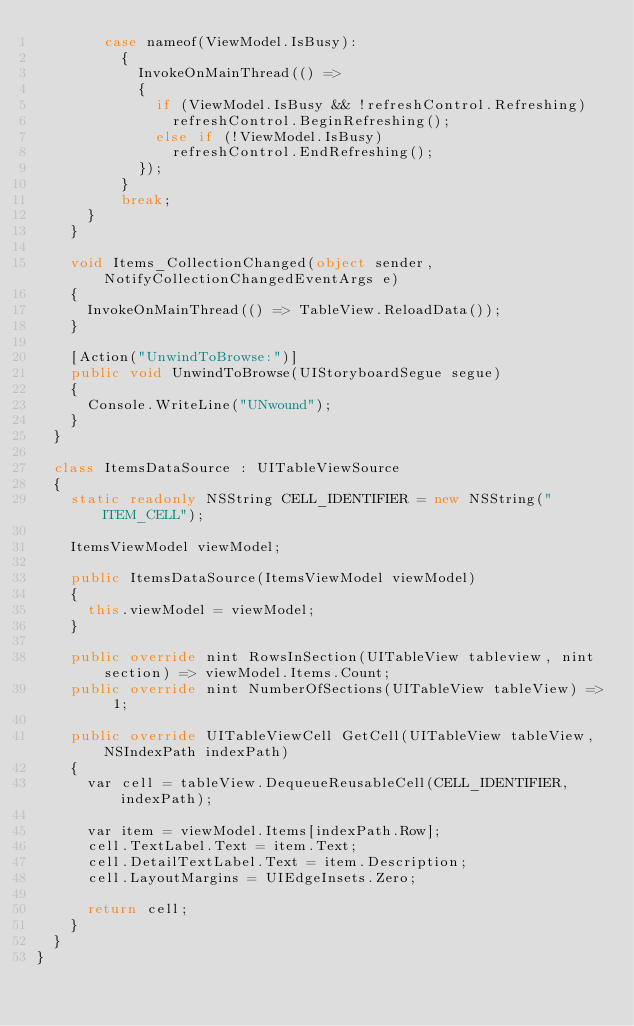<code> <loc_0><loc_0><loc_500><loc_500><_C#_>				case nameof(ViewModel.IsBusy):
					{
						InvokeOnMainThread(() =>
						{
							if (ViewModel.IsBusy && !refreshControl.Refreshing)
								refreshControl.BeginRefreshing();
							else if (!ViewModel.IsBusy)
								refreshControl.EndRefreshing();
						});
					}
					break;
			}
		}

		void Items_CollectionChanged(object sender, NotifyCollectionChangedEventArgs e)
		{
			InvokeOnMainThread(() => TableView.ReloadData());
		}

		[Action("UnwindToBrowse:")]
		public void UnwindToBrowse(UIStoryboardSegue segue)
		{
			Console.WriteLine("UNwound");
		}
	}

	class ItemsDataSource : UITableViewSource
	{
		static readonly NSString CELL_IDENTIFIER = new NSString("ITEM_CELL");

		ItemsViewModel viewModel;

		public ItemsDataSource(ItemsViewModel viewModel)
		{
			this.viewModel = viewModel;
		}

		public override nint RowsInSection(UITableView tableview, nint section) => viewModel.Items.Count;
		public override nint NumberOfSections(UITableView tableView) => 1;

		public override UITableViewCell GetCell(UITableView tableView, NSIndexPath indexPath)
		{
			var cell = tableView.DequeueReusableCell(CELL_IDENTIFIER, indexPath);

			var item = viewModel.Items[indexPath.Row];
			cell.TextLabel.Text = item.Text;
			cell.DetailTextLabel.Text = item.Description;
			cell.LayoutMargins = UIEdgeInsets.Zero;

			return cell;
		}
	}
}</code> 